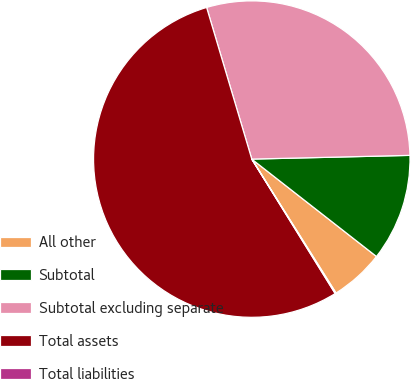<chart> <loc_0><loc_0><loc_500><loc_500><pie_chart><fcel>All other<fcel>Subtotal<fcel>Subtotal excluding separate<fcel>Total assets<fcel>Total liabilities<nl><fcel>5.51%<fcel>10.93%<fcel>29.23%<fcel>54.23%<fcel>0.1%<nl></chart> 